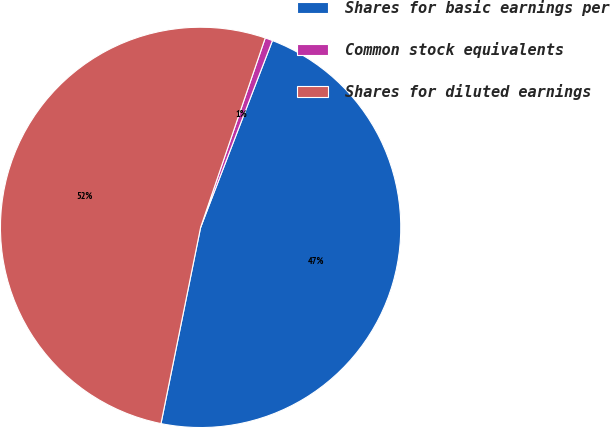Convert chart to OTSL. <chart><loc_0><loc_0><loc_500><loc_500><pie_chart><fcel>Shares for basic earnings per<fcel>Common stock equivalents<fcel>Shares for diluted earnings<nl><fcel>47.33%<fcel>0.61%<fcel>52.06%<nl></chart> 